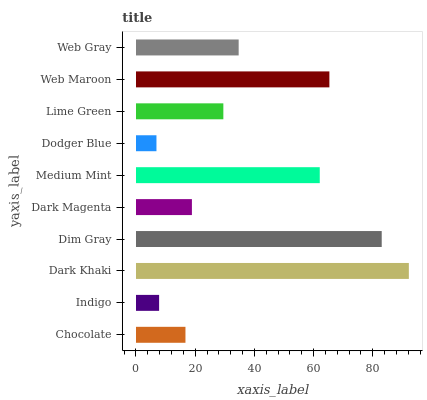Is Dodger Blue the minimum?
Answer yes or no. Yes. Is Dark Khaki the maximum?
Answer yes or no. Yes. Is Indigo the minimum?
Answer yes or no. No. Is Indigo the maximum?
Answer yes or no. No. Is Chocolate greater than Indigo?
Answer yes or no. Yes. Is Indigo less than Chocolate?
Answer yes or no. Yes. Is Indigo greater than Chocolate?
Answer yes or no. No. Is Chocolate less than Indigo?
Answer yes or no. No. Is Web Gray the high median?
Answer yes or no. Yes. Is Lime Green the low median?
Answer yes or no. Yes. Is Medium Mint the high median?
Answer yes or no. No. Is Dark Magenta the low median?
Answer yes or no. No. 